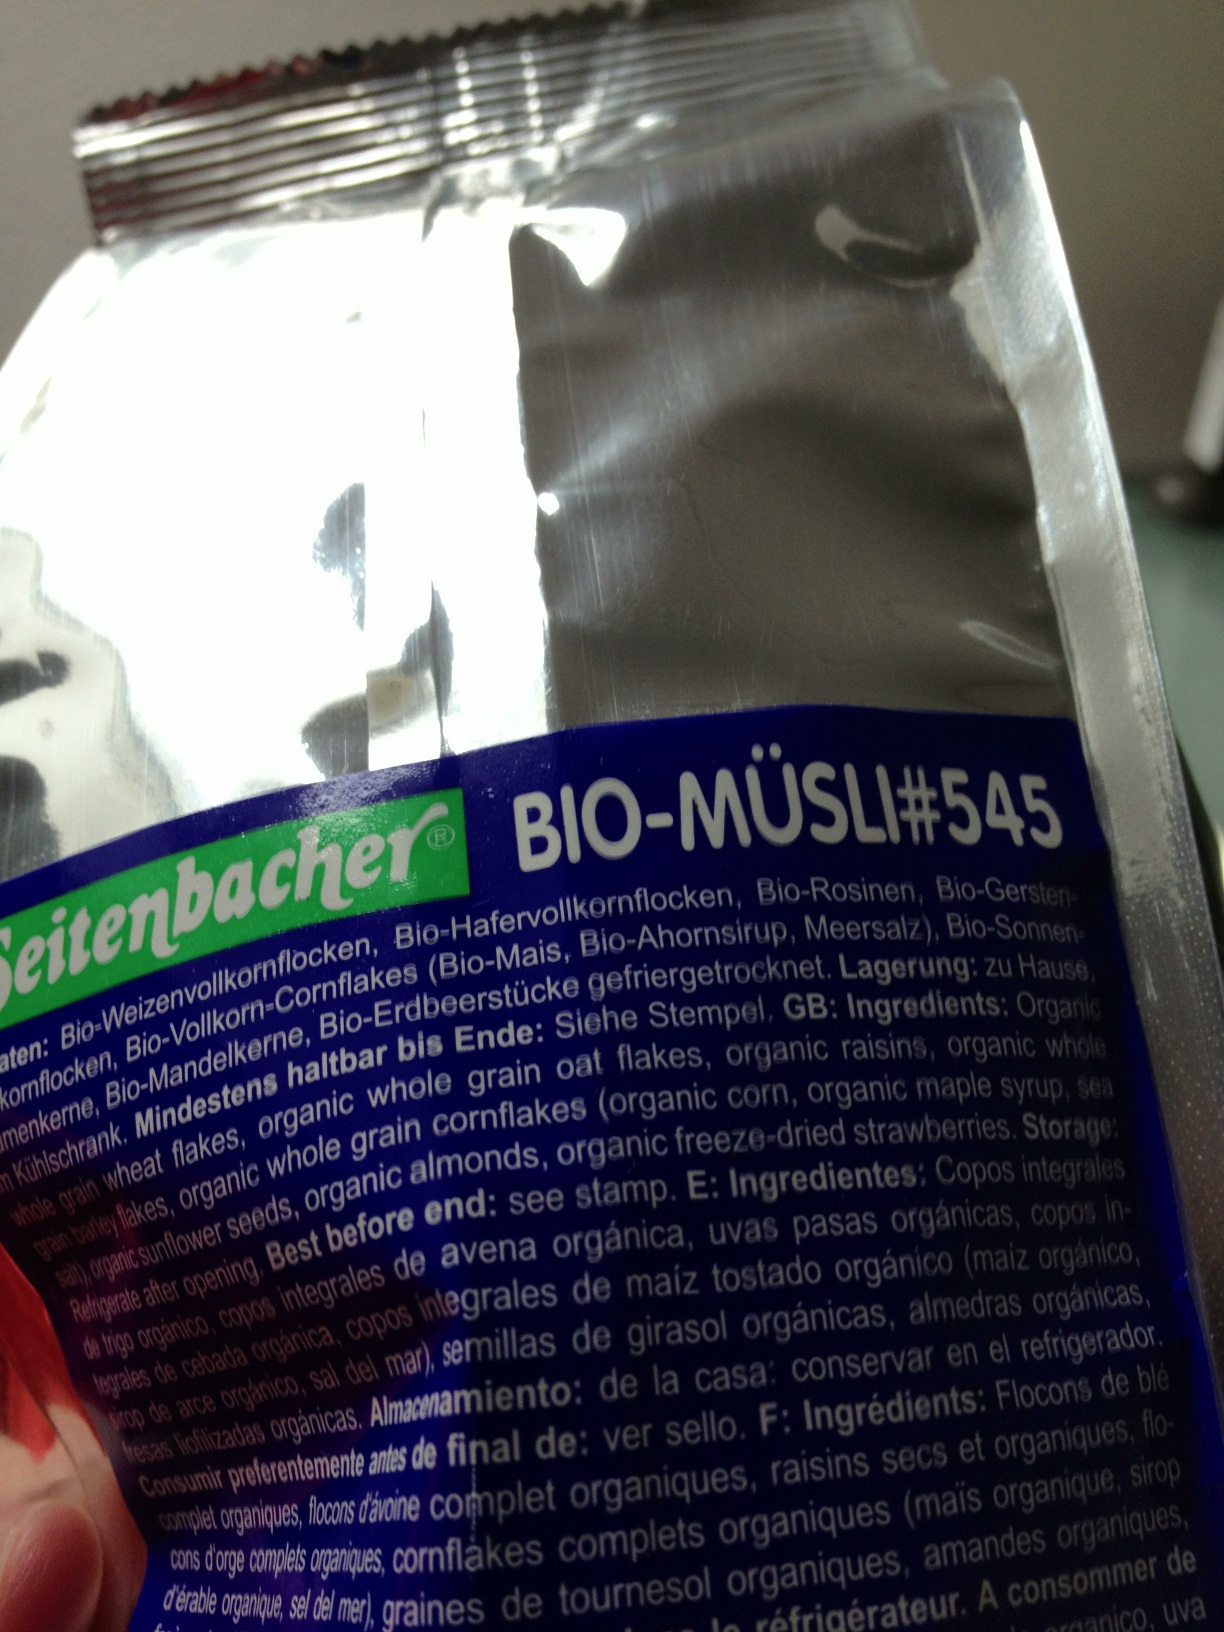Can you list the organic ingredients mentioned on this package? The packaging lists several organic ingredients, including organic whole wheat, organic raisins, organic barley flakes, organic corn, organic maple syrup, and organic freeze-dried strawberries. 